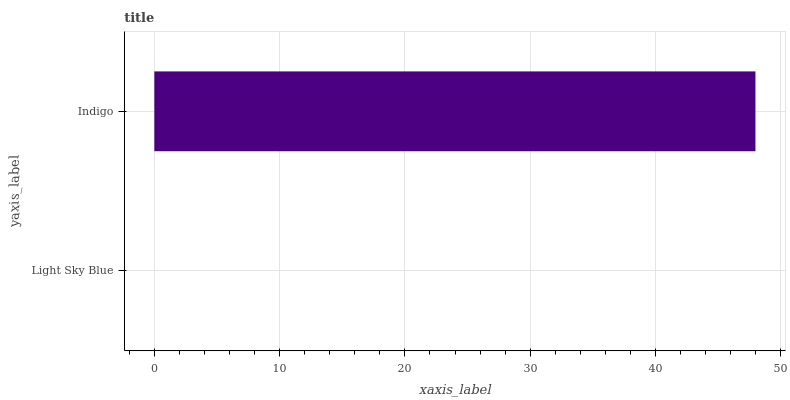Is Light Sky Blue the minimum?
Answer yes or no. Yes. Is Indigo the maximum?
Answer yes or no. Yes. Is Indigo the minimum?
Answer yes or no. No. Is Indigo greater than Light Sky Blue?
Answer yes or no. Yes. Is Light Sky Blue less than Indigo?
Answer yes or no. Yes. Is Light Sky Blue greater than Indigo?
Answer yes or no. No. Is Indigo less than Light Sky Blue?
Answer yes or no. No. Is Indigo the high median?
Answer yes or no. Yes. Is Light Sky Blue the low median?
Answer yes or no. Yes. Is Light Sky Blue the high median?
Answer yes or no. No. Is Indigo the low median?
Answer yes or no. No. 